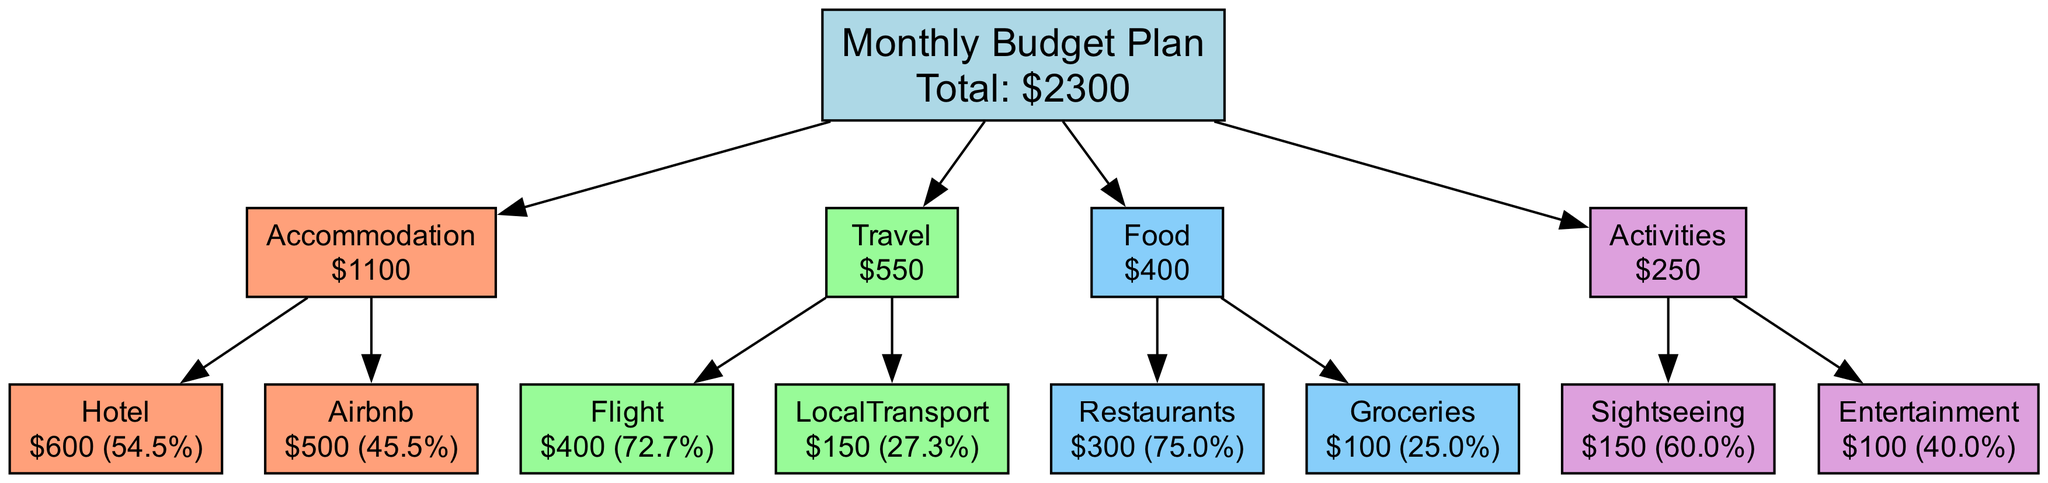What is the total budget for the vacation? By aggregating all the amounts from each category (Accommodation, Travel, Food, and Activities), we sum up: 600 + 500 + 400 + 150 + 300 + 100 + 150 + 100 = 2300.
Answer: 2300 How much is allocated for food? The food category includes two subcategories: Restaurants costing 300 and Groceries costing 100. Adding these gives us 300 + 100 = 400 for food.
Answer: 400 Which category has the highest total cost? By reviewing the totals for each category, we find: Accommodation (1100), Travel (550), Food (400), Activities (250). The highest total is Accommodation at 1100.
Answer: Accommodation What percentage of the total budget is spent on activities? The total spent on Activities is 250. To find the percentage, we calculate (250 / 2300) * 100, which gives approximately 10.9%.
Answer: 10.9% How many subcategories are there under Travel? The Travel category contains two subcategories: Flight and Local Transport, leading to a total count of 2 subcategories.
Answer: 2 What is the cost for the sightseeing tours? The amount allocated specifically for Sightseeing, under Activities, is directly stated as 150.
Answer: 150 What is the lowest amount spent on a single category? When evaluating the total amounts for each category, Food (400) is the lowest amount when compared to Accommodation (1100), Travel (550), and Activities (250).
Answer: Activities Which subcategory costs the most within Accommodation? The two subcategories under Accommodation are Hotel (600) and Airbnb (500). Comparing these, the Hotel is the highest at 600.
Answer: Hotel What do the colors represent in the diagram? The colors are used to visually differentiate categories: Accommodation is light salmon, Travel is light green, Food is light blue, and Activities is light purple.
Answer: Different categories 